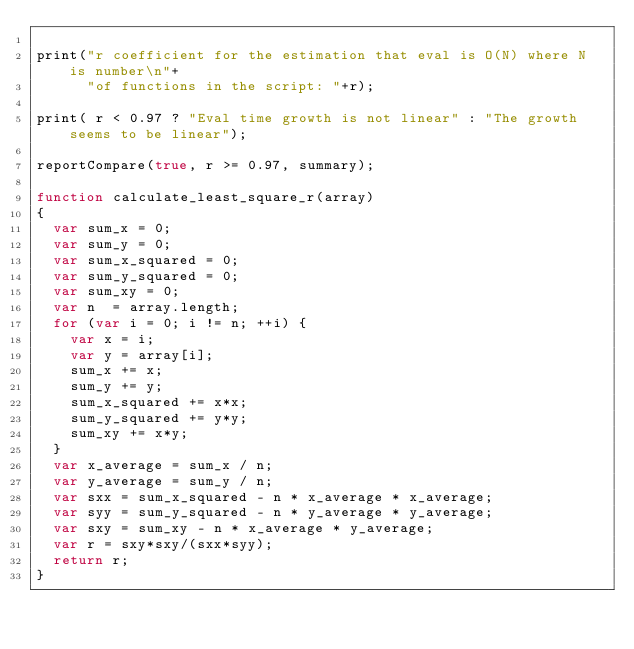<code> <loc_0><loc_0><loc_500><loc_500><_JavaScript_>
print("r coefficient for the estimation that eval is O(N) where N is number\n"+
      "of functions in the script: "+r);

print( r < 0.97 ? "Eval time growth is not linear" : "The growth seems to be linear");

reportCompare(true, r >= 0.97, summary);

function calculate_least_square_r(array)
{
  var sum_x = 0;
  var sum_y = 0;
  var sum_x_squared = 0;
  var sum_y_squared = 0;
  var sum_xy = 0;
  var n  = array.length;
  for (var i = 0; i != n; ++i) {
    var x = i;
    var y = array[i];
    sum_x += x;
    sum_y += y;
    sum_x_squared += x*x;
    sum_y_squared += y*y;
    sum_xy += x*y;
  }
  var x_average = sum_x / n;
  var y_average = sum_y / n;
  var sxx = sum_x_squared - n * x_average * x_average;
  var syy = sum_y_squared - n * y_average * y_average;
  var sxy = sum_xy - n * x_average * y_average;
  var r = sxy*sxy/(sxx*syy);
  return r;
}
 
</code> 